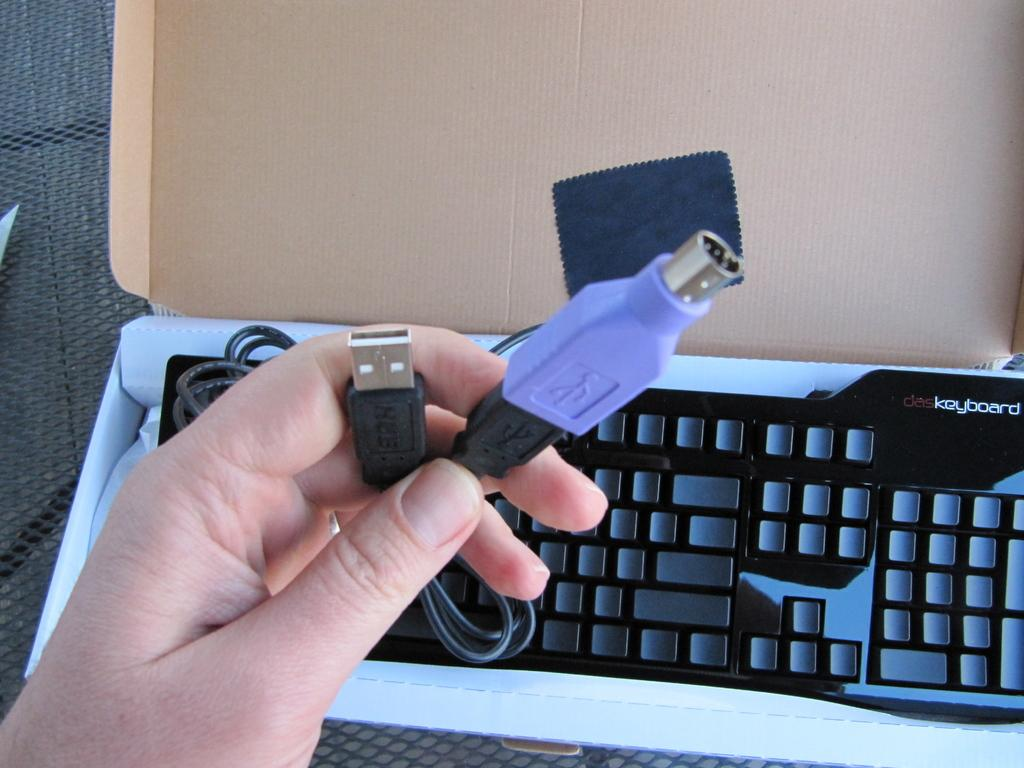<image>
Present a compact description of the photo's key features. The USB cords need to plug into the DAS Keyboard. 